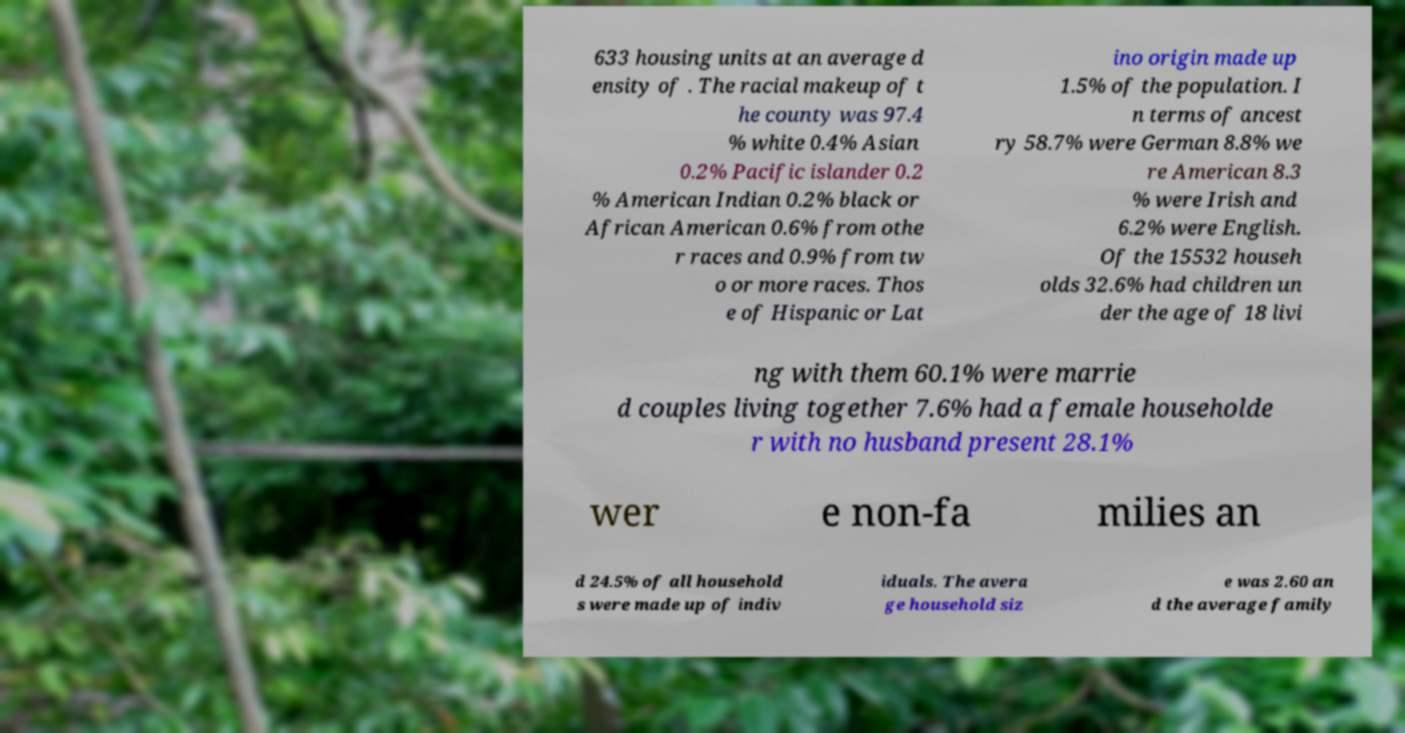There's text embedded in this image that I need extracted. Can you transcribe it verbatim? 633 housing units at an average d ensity of . The racial makeup of t he county was 97.4 % white 0.4% Asian 0.2% Pacific islander 0.2 % American Indian 0.2% black or African American 0.6% from othe r races and 0.9% from tw o or more races. Thos e of Hispanic or Lat ino origin made up 1.5% of the population. I n terms of ancest ry 58.7% were German 8.8% we re American 8.3 % were Irish and 6.2% were English. Of the 15532 househ olds 32.6% had children un der the age of 18 livi ng with them 60.1% were marrie d couples living together 7.6% had a female householde r with no husband present 28.1% wer e non-fa milies an d 24.5% of all household s were made up of indiv iduals. The avera ge household siz e was 2.60 an d the average family 